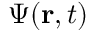Convert formula to latex. <formula><loc_0><loc_0><loc_500><loc_500>\Psi ( r , t )</formula> 